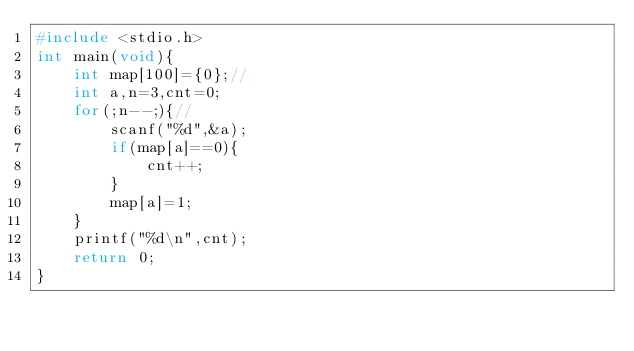Convert code to text. <code><loc_0><loc_0><loc_500><loc_500><_C_>#include <stdio.h>
int main(void){
    int map[100]={0};//
    int a,n=3,cnt=0;
    for(;n--;){//
        scanf("%d",&a);
        if(map[a]==0){
            cnt++;
        }
        map[a]=1;
    }
    printf("%d\n",cnt);
    return 0;
}
</code> 